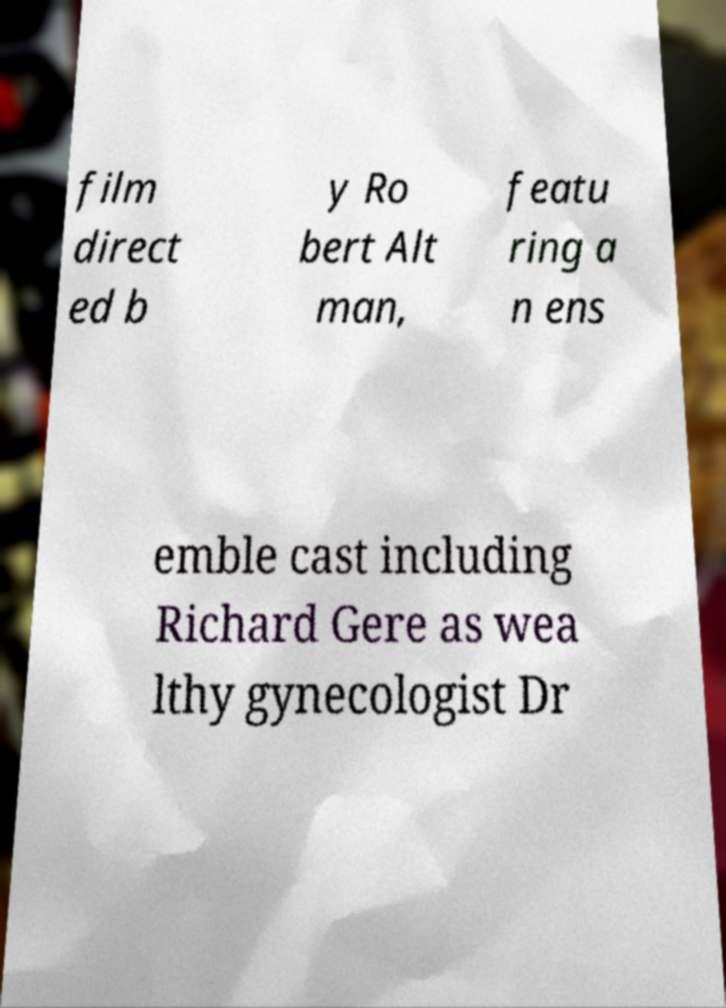I need the written content from this picture converted into text. Can you do that? film direct ed b y Ro bert Alt man, featu ring a n ens emble cast including Richard Gere as wea lthy gynecologist Dr 